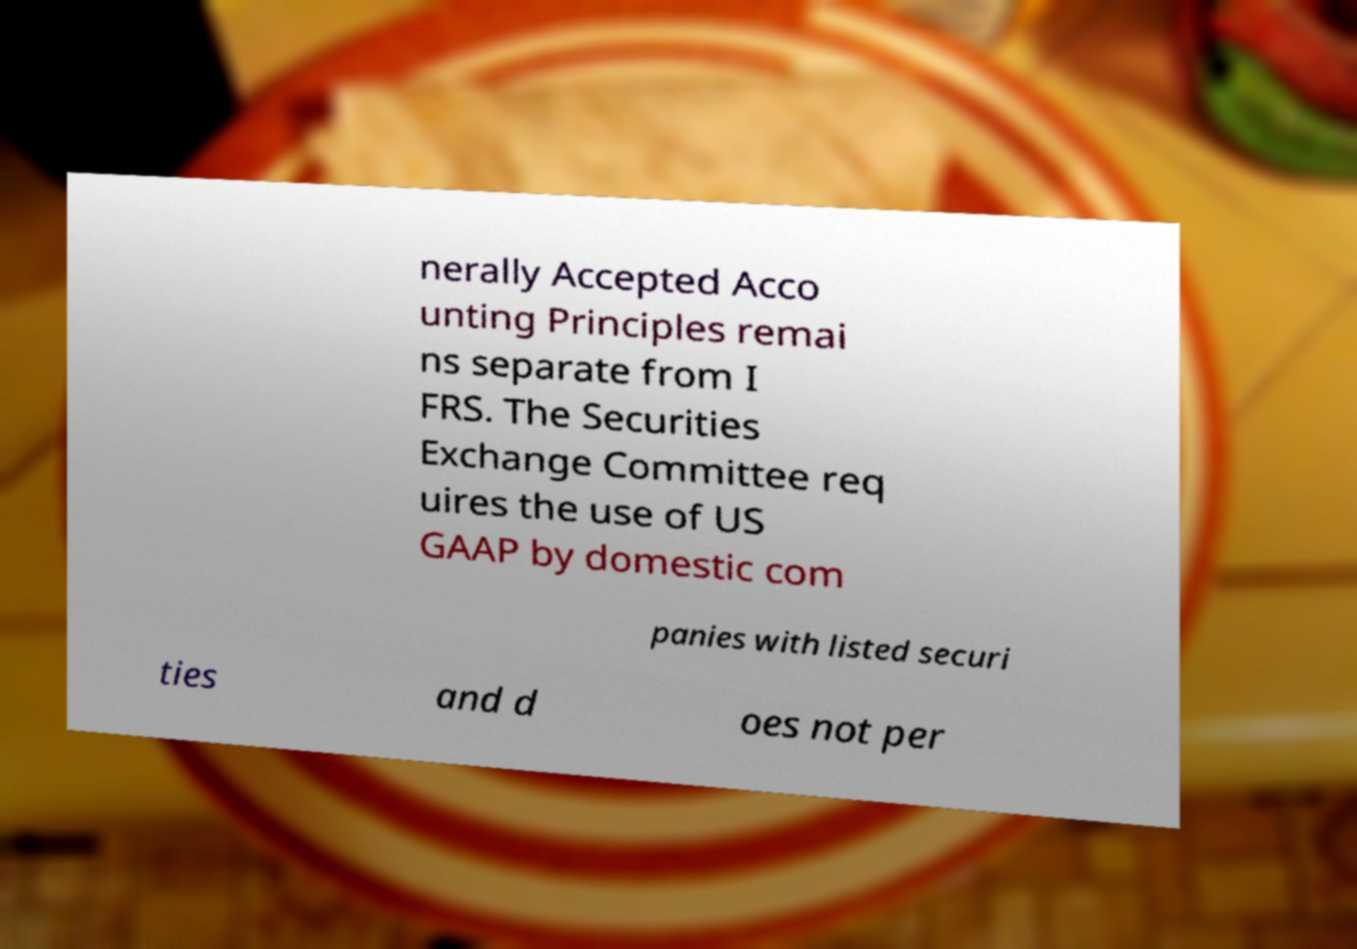What messages or text are displayed in this image? I need them in a readable, typed format. nerally Accepted Acco unting Principles remai ns separate from I FRS. The Securities Exchange Committee req uires the use of US GAAP by domestic com panies with listed securi ties and d oes not per 